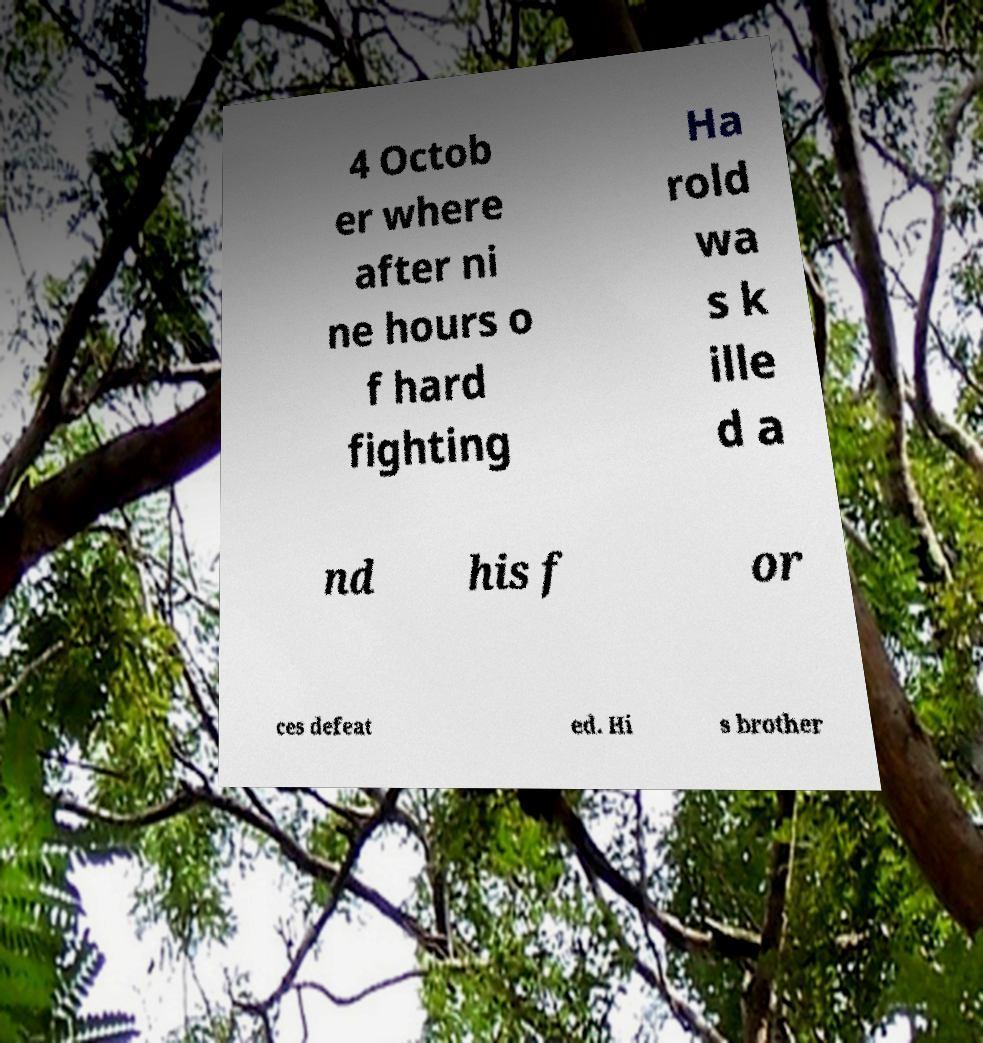I need the written content from this picture converted into text. Can you do that? 4 Octob er where after ni ne hours o f hard fighting Ha rold wa s k ille d a nd his f or ces defeat ed. Hi s brother 